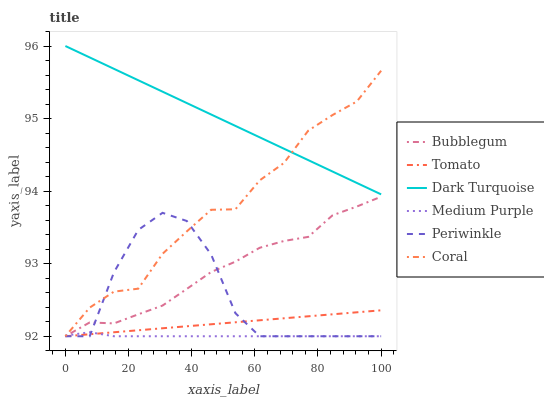Does Medium Purple have the minimum area under the curve?
Answer yes or no. Yes. Does Dark Turquoise have the maximum area under the curve?
Answer yes or no. Yes. Does Coral have the minimum area under the curve?
Answer yes or no. No. Does Coral have the maximum area under the curve?
Answer yes or no. No. Is Tomato the smoothest?
Answer yes or no. Yes. Is Periwinkle the roughest?
Answer yes or no. Yes. Is Dark Turquoise the smoothest?
Answer yes or no. No. Is Dark Turquoise the roughest?
Answer yes or no. No. Does Tomato have the lowest value?
Answer yes or no. Yes. Does Dark Turquoise have the lowest value?
Answer yes or no. No. Does Dark Turquoise have the highest value?
Answer yes or no. Yes. Does Coral have the highest value?
Answer yes or no. No. Is Medium Purple less than Dark Turquoise?
Answer yes or no. Yes. Is Dark Turquoise greater than Bubblegum?
Answer yes or no. Yes. Does Bubblegum intersect Periwinkle?
Answer yes or no. Yes. Is Bubblegum less than Periwinkle?
Answer yes or no. No. Is Bubblegum greater than Periwinkle?
Answer yes or no. No. Does Medium Purple intersect Dark Turquoise?
Answer yes or no. No. 